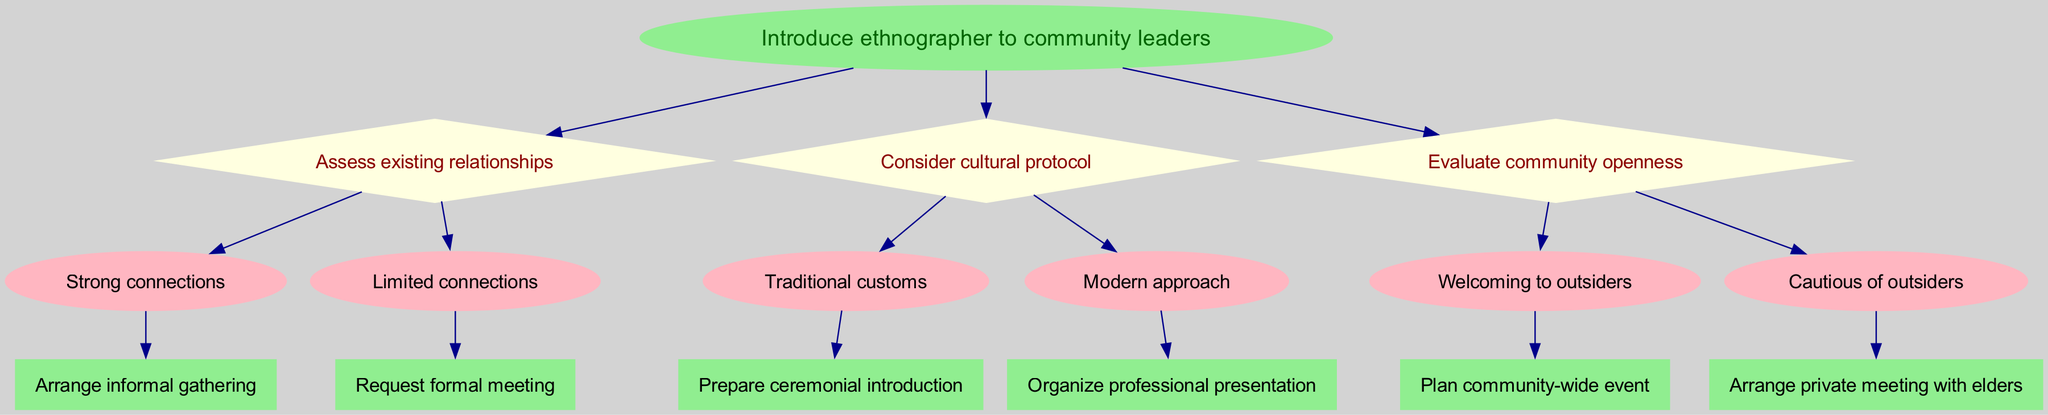What is the root node of the diagram? The root node of the diagram is the starting point, which is explicitly stated at the top as "Introduce ethnographer to community leaders."
Answer: Introduce ethnographer to community leaders How many decision nodes are in the diagram? There are three decision nodes in the diagram: "Assess existing relationships," "Consider cultural protocol," and "Evaluate community openness." Each of these nodes represents a decision-making point.
Answer: 3 What is the result if community openness is evaluated as "Welcoming to outsiders"? If community openness is evaluated as "Welcoming to outsiders," the next step in the decision tree indicates that the result would be to "Plan community-wide event."
Answer: Plan community-wide event If the connections are assessed as "Limited connections," what is the next action suggested? When the connections are assessed as "Limited connections," the diagram suggests that the next action is to "Request formal meeting." This follows directly from that option of the decision node.
Answer: Request formal meeting What is the choice leading to a "Prepare ceremonial introduction"? The diagram indicates that if traditional customs are considered under the decision node "Consider cultural protocol," the path leads to the option "Prepare ceremonial introduction."
Answer: Traditional customs In which case would you arrange a private meeting with elders? A private meeting with elders is arranged if community openness is evaluated as "Cautious of outsiders." This follows the diagram's specific flow for that decision point.
Answer: Cautious of outsiders What color are the nodes representing results in the diagram? The nodes that represent results in the decision tree are colored light green, indicating successful outcomes or actions to be taken.
Answer: Light green Which decision node has the option "Organize professional presentation"? The option "Organize professional presentation" is under the decision node "Consider cultural protocol." This is where the approach is decided based on modern customs.
Answer: Consider cultural protocol 